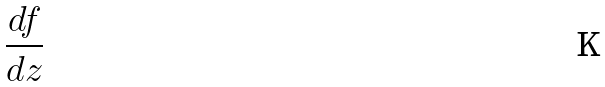Convert formula to latex. <formula><loc_0><loc_0><loc_500><loc_500>\frac { d f } { d z }</formula> 